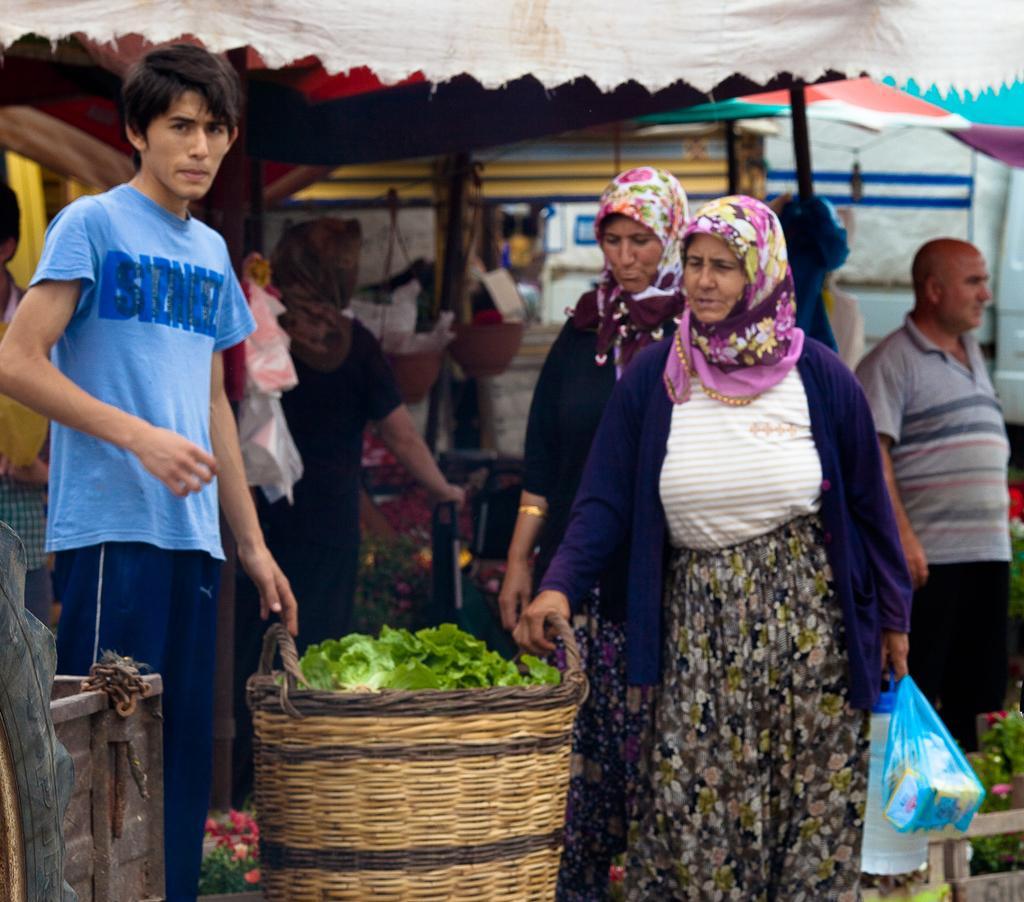In one or two sentences, can you explain what this image depicts? There are many people. Some are wearing scarf. Lady in the front is holding packets. Near to her there is a basket with leaves. In the background there are tents. Also there are many flowering plants. 